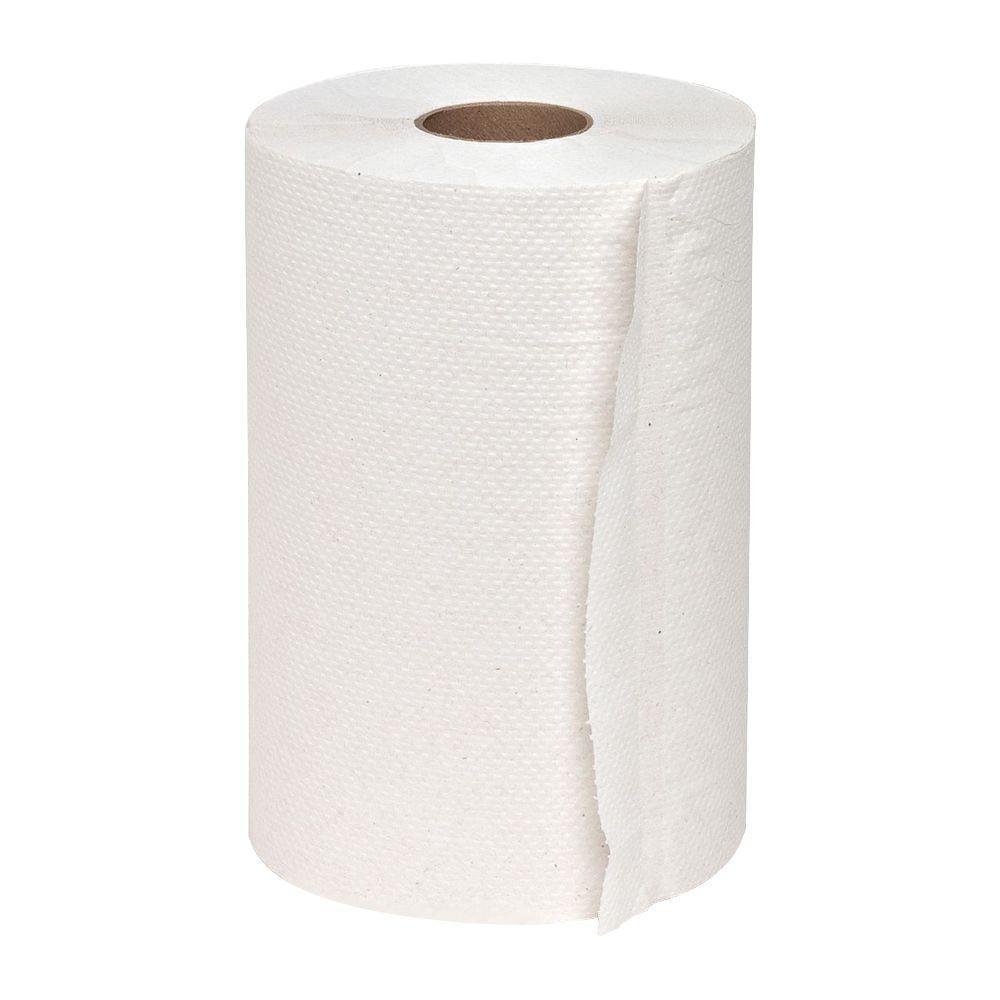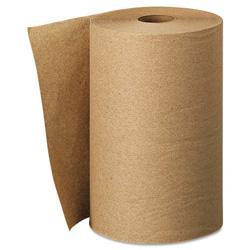The first image is the image on the left, the second image is the image on the right. For the images displayed, is the sentence "The roll of paper in one of the image is brown." factually correct? Answer yes or no. Yes. The first image is the image on the left, the second image is the image on the right. Given the left and right images, does the statement "An image features one upright towel row the color of brown kraft paper." hold true? Answer yes or no. Yes. 